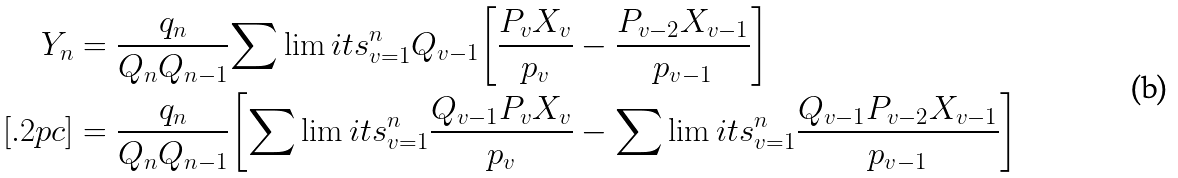<formula> <loc_0><loc_0><loc_500><loc_500>Y _ { n } & = { \frac { { q _ { n } } } { { Q _ { n } Q _ { n - 1 } } } } { \sum \lim i t s _ { v = 1 } ^ { n } { Q _ { v - 1 } } } { \left [ { { \frac { { P _ { v } X _ { v } } } { { p _ { v } } } } - { \frac { { P _ { v - 2 } X _ { v - 1 } } } { { p _ { v - 1 } } } } } \right ] } \\ [ . 2 p c ] & = { \frac { { q _ { n } } } { { Q _ { n } Q _ { n - 1 } } } } { \left [ { { \sum \lim i t s _ { v = 1 } ^ { n } { { \frac { { Q _ { v - 1 } P _ { v } X _ { v } } } { { p _ { v } } } } } } - { \sum \lim i t s _ { v = 1 } ^ { n } { { \frac { { Q _ { v - 1 } P _ { v - 2 } X _ { v - 1 } } } { { p _ { v - 1 } } } } } } } \right ] }</formula> 